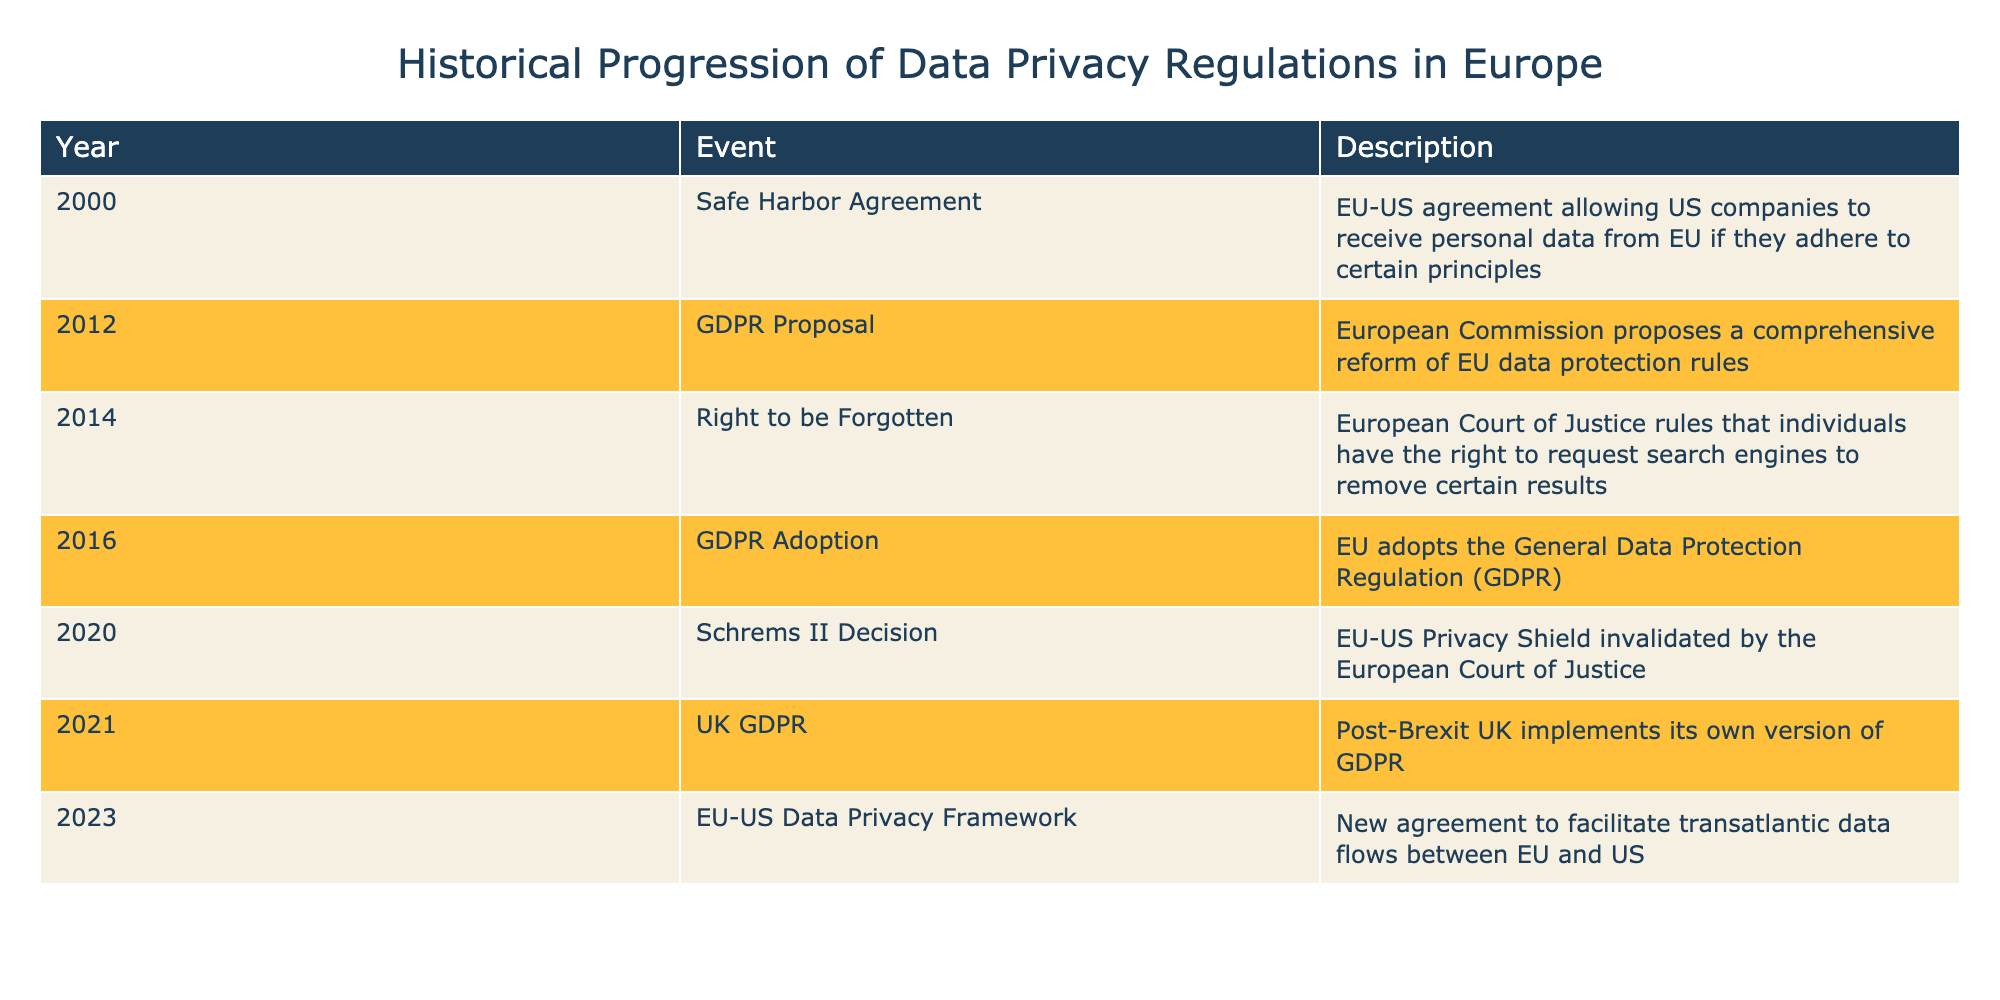What year was the GDPR adopted? The table specifies the event of GDPR Adoption, which is listed under the year 2016.
Answer: 2016 What event occurred immediately before the UK GDPR was implemented? The UK GDPR event is associated with the year 2021, and looking at the table, the event that occurred immediately before it is the Schrems II Decision from 2020.
Answer: Schrems II Decision How many years were there between the Safe Harbor Agreement and the GDPR Proposal? The Safe Harbor Agreement occurred in 2000 and the GDPR Proposal in 2012. The difference in years is 2012 - 2000 = 12 years.
Answer: 12 years Did the EU adopt the GDPR before or after the Right to be Forgotten ruling? The table indicates the GDPR Adoption in 2016 and the Right to be Forgotten ruling in 2014. Since 2016 is after 2014, the GDPR was adopted later.
Answer: After Which event was a response to the invalidation of the Privacy Shield? The event that directly follows the invalidation of the Privacy Shield is the EU-US Data Privacy Framework established in 2023, as listed in the table.
Answer: EU-US Data Privacy Framework What was the chronological order of the events leading up to the GDPR? The events in chronological order leading to the GDPR are: Safe Harbor Agreement (2000), GDPR Proposal (2012), GDPR Adoption (2016). This is deduced from the years listed next to each event.
Answer: Safe Harbor Agreement, GDPR Proposal, GDPR Adoption What is the main significance of the Schrems II Decision in relation to data privacy? The Schrems II Decision invalidated the EU-US Privacy Shield, which was crucial for transatlantic data flows, indicating that it directly impacted how personal data is handled between the EU and the US.
Answer: It invalidated the EU-US Privacy Shield How many significant events related to data privacy occurred after 2016? From the table, the events after 2016 are the UK GDPR in 2021 and the EU-US Data Privacy Framework in 2023, making a total of 2 significant events.
Answer: 2 events Was the Right to be Forgotten enacted before the GDPR Proposal? Yes, the Right to be Forgotten ruling occurred in 2014, which is before the GDPR Proposal in 2012. This can be confirmed by looking at the years associated with each event in the table.
Answer: No 